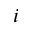Convert formula to latex. <formula><loc_0><loc_0><loc_500><loc_500>i</formula> 